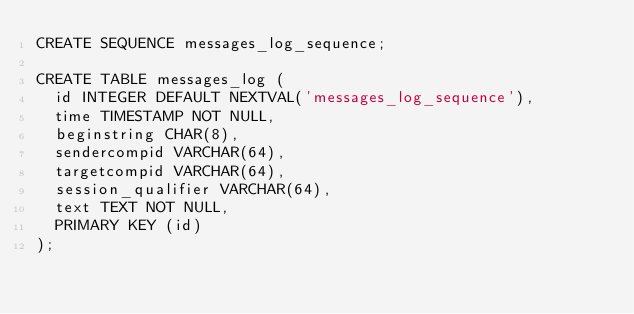Convert code to text. <code><loc_0><loc_0><loc_500><loc_500><_SQL_>CREATE SEQUENCE messages_log_sequence;

CREATE TABLE messages_log (
  id INTEGER DEFAULT NEXTVAL('messages_log_sequence'),
  time TIMESTAMP NOT NULL,
  beginstring CHAR(8),
  sendercompid VARCHAR(64),
  targetcompid VARCHAR(64),
  session_qualifier VARCHAR(64),
  text TEXT NOT NULL,
  PRIMARY KEY (id)
);
</code> 